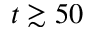<formula> <loc_0><loc_0><loc_500><loc_500>t \gtrsim 5 0</formula> 